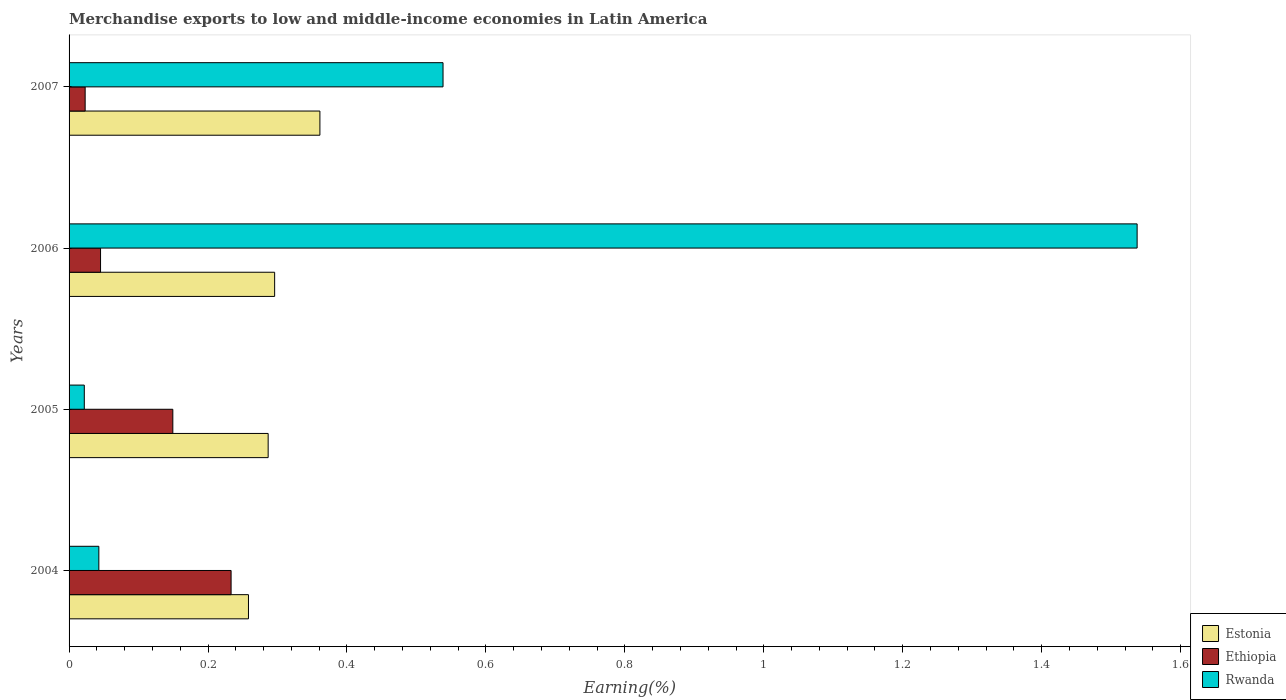How many different coloured bars are there?
Offer a very short reply. 3. How many groups of bars are there?
Offer a terse response. 4. How many bars are there on the 3rd tick from the bottom?
Provide a short and direct response. 3. What is the label of the 1st group of bars from the top?
Your response must be concise. 2007. In how many cases, is the number of bars for a given year not equal to the number of legend labels?
Give a very brief answer. 0. What is the percentage of amount earned from merchandise exports in Ethiopia in 2006?
Offer a very short reply. 0.05. Across all years, what is the maximum percentage of amount earned from merchandise exports in Estonia?
Keep it short and to the point. 0.36. Across all years, what is the minimum percentage of amount earned from merchandise exports in Rwanda?
Your response must be concise. 0.02. In which year was the percentage of amount earned from merchandise exports in Rwanda maximum?
Your answer should be compact. 2006. What is the total percentage of amount earned from merchandise exports in Ethiopia in the graph?
Provide a succinct answer. 0.45. What is the difference between the percentage of amount earned from merchandise exports in Ethiopia in 2004 and that in 2007?
Keep it short and to the point. 0.21. What is the difference between the percentage of amount earned from merchandise exports in Estonia in 2004 and the percentage of amount earned from merchandise exports in Ethiopia in 2007?
Offer a terse response. 0.24. What is the average percentage of amount earned from merchandise exports in Ethiopia per year?
Your response must be concise. 0.11. In the year 2007, what is the difference between the percentage of amount earned from merchandise exports in Rwanda and percentage of amount earned from merchandise exports in Estonia?
Provide a succinct answer. 0.18. In how many years, is the percentage of amount earned from merchandise exports in Rwanda greater than 1 %?
Keep it short and to the point. 1. What is the ratio of the percentage of amount earned from merchandise exports in Estonia in 2005 to that in 2007?
Offer a terse response. 0.79. Is the percentage of amount earned from merchandise exports in Ethiopia in 2004 less than that in 2005?
Provide a succinct answer. No. Is the difference between the percentage of amount earned from merchandise exports in Rwanda in 2004 and 2006 greater than the difference between the percentage of amount earned from merchandise exports in Estonia in 2004 and 2006?
Provide a short and direct response. No. What is the difference between the highest and the second highest percentage of amount earned from merchandise exports in Ethiopia?
Offer a terse response. 0.08. What is the difference between the highest and the lowest percentage of amount earned from merchandise exports in Estonia?
Your response must be concise. 0.1. What does the 3rd bar from the top in 2006 represents?
Offer a very short reply. Estonia. What does the 3rd bar from the bottom in 2005 represents?
Offer a very short reply. Rwanda. How many bars are there?
Give a very brief answer. 12. Are all the bars in the graph horizontal?
Your answer should be very brief. Yes. How many years are there in the graph?
Give a very brief answer. 4. Are the values on the major ticks of X-axis written in scientific E-notation?
Your answer should be compact. No. Does the graph contain grids?
Offer a very short reply. No. Where does the legend appear in the graph?
Ensure brevity in your answer.  Bottom right. How are the legend labels stacked?
Make the answer very short. Vertical. What is the title of the graph?
Offer a very short reply. Merchandise exports to low and middle-income economies in Latin America. Does "Peru" appear as one of the legend labels in the graph?
Your answer should be compact. No. What is the label or title of the X-axis?
Give a very brief answer. Earning(%). What is the label or title of the Y-axis?
Keep it short and to the point. Years. What is the Earning(%) in Estonia in 2004?
Offer a terse response. 0.26. What is the Earning(%) in Ethiopia in 2004?
Offer a very short reply. 0.23. What is the Earning(%) in Rwanda in 2004?
Provide a short and direct response. 0.04. What is the Earning(%) in Estonia in 2005?
Give a very brief answer. 0.29. What is the Earning(%) in Ethiopia in 2005?
Make the answer very short. 0.15. What is the Earning(%) of Rwanda in 2005?
Your answer should be compact. 0.02. What is the Earning(%) of Estonia in 2006?
Ensure brevity in your answer.  0.3. What is the Earning(%) in Ethiopia in 2006?
Keep it short and to the point. 0.05. What is the Earning(%) in Rwanda in 2006?
Make the answer very short. 1.54. What is the Earning(%) in Estonia in 2007?
Your answer should be very brief. 0.36. What is the Earning(%) in Ethiopia in 2007?
Keep it short and to the point. 0.02. What is the Earning(%) in Rwanda in 2007?
Your answer should be very brief. 0.54. Across all years, what is the maximum Earning(%) of Estonia?
Give a very brief answer. 0.36. Across all years, what is the maximum Earning(%) in Ethiopia?
Your answer should be compact. 0.23. Across all years, what is the maximum Earning(%) in Rwanda?
Ensure brevity in your answer.  1.54. Across all years, what is the minimum Earning(%) of Estonia?
Offer a terse response. 0.26. Across all years, what is the minimum Earning(%) of Ethiopia?
Give a very brief answer. 0.02. Across all years, what is the minimum Earning(%) of Rwanda?
Provide a succinct answer. 0.02. What is the total Earning(%) of Estonia in the graph?
Your answer should be very brief. 1.2. What is the total Earning(%) in Ethiopia in the graph?
Ensure brevity in your answer.  0.45. What is the total Earning(%) in Rwanda in the graph?
Provide a short and direct response. 2.14. What is the difference between the Earning(%) of Estonia in 2004 and that in 2005?
Your answer should be very brief. -0.03. What is the difference between the Earning(%) in Ethiopia in 2004 and that in 2005?
Provide a short and direct response. 0.08. What is the difference between the Earning(%) in Rwanda in 2004 and that in 2005?
Offer a terse response. 0.02. What is the difference between the Earning(%) in Estonia in 2004 and that in 2006?
Provide a short and direct response. -0.04. What is the difference between the Earning(%) of Ethiopia in 2004 and that in 2006?
Make the answer very short. 0.19. What is the difference between the Earning(%) of Rwanda in 2004 and that in 2006?
Your answer should be compact. -1.49. What is the difference between the Earning(%) in Estonia in 2004 and that in 2007?
Give a very brief answer. -0.1. What is the difference between the Earning(%) in Ethiopia in 2004 and that in 2007?
Keep it short and to the point. 0.21. What is the difference between the Earning(%) of Rwanda in 2004 and that in 2007?
Your answer should be compact. -0.5. What is the difference between the Earning(%) in Estonia in 2005 and that in 2006?
Give a very brief answer. -0.01. What is the difference between the Earning(%) in Ethiopia in 2005 and that in 2006?
Offer a very short reply. 0.1. What is the difference between the Earning(%) in Rwanda in 2005 and that in 2006?
Provide a short and direct response. -1.52. What is the difference between the Earning(%) in Estonia in 2005 and that in 2007?
Give a very brief answer. -0.07. What is the difference between the Earning(%) of Ethiopia in 2005 and that in 2007?
Ensure brevity in your answer.  0.13. What is the difference between the Earning(%) in Rwanda in 2005 and that in 2007?
Ensure brevity in your answer.  -0.52. What is the difference between the Earning(%) of Estonia in 2006 and that in 2007?
Make the answer very short. -0.07. What is the difference between the Earning(%) of Ethiopia in 2006 and that in 2007?
Your answer should be very brief. 0.02. What is the difference between the Earning(%) of Rwanda in 2006 and that in 2007?
Offer a terse response. 1. What is the difference between the Earning(%) of Estonia in 2004 and the Earning(%) of Ethiopia in 2005?
Give a very brief answer. 0.11. What is the difference between the Earning(%) of Estonia in 2004 and the Earning(%) of Rwanda in 2005?
Your answer should be very brief. 0.24. What is the difference between the Earning(%) in Ethiopia in 2004 and the Earning(%) in Rwanda in 2005?
Your response must be concise. 0.21. What is the difference between the Earning(%) in Estonia in 2004 and the Earning(%) in Ethiopia in 2006?
Keep it short and to the point. 0.21. What is the difference between the Earning(%) of Estonia in 2004 and the Earning(%) of Rwanda in 2006?
Keep it short and to the point. -1.28. What is the difference between the Earning(%) in Ethiopia in 2004 and the Earning(%) in Rwanda in 2006?
Provide a short and direct response. -1.3. What is the difference between the Earning(%) in Estonia in 2004 and the Earning(%) in Ethiopia in 2007?
Make the answer very short. 0.24. What is the difference between the Earning(%) in Estonia in 2004 and the Earning(%) in Rwanda in 2007?
Provide a short and direct response. -0.28. What is the difference between the Earning(%) of Ethiopia in 2004 and the Earning(%) of Rwanda in 2007?
Keep it short and to the point. -0.31. What is the difference between the Earning(%) in Estonia in 2005 and the Earning(%) in Ethiopia in 2006?
Provide a succinct answer. 0.24. What is the difference between the Earning(%) in Estonia in 2005 and the Earning(%) in Rwanda in 2006?
Ensure brevity in your answer.  -1.25. What is the difference between the Earning(%) of Ethiopia in 2005 and the Earning(%) of Rwanda in 2006?
Your answer should be very brief. -1.39. What is the difference between the Earning(%) of Estonia in 2005 and the Earning(%) of Ethiopia in 2007?
Keep it short and to the point. 0.26. What is the difference between the Earning(%) in Estonia in 2005 and the Earning(%) in Rwanda in 2007?
Make the answer very short. -0.25. What is the difference between the Earning(%) of Ethiopia in 2005 and the Earning(%) of Rwanda in 2007?
Ensure brevity in your answer.  -0.39. What is the difference between the Earning(%) of Estonia in 2006 and the Earning(%) of Ethiopia in 2007?
Give a very brief answer. 0.27. What is the difference between the Earning(%) in Estonia in 2006 and the Earning(%) in Rwanda in 2007?
Provide a short and direct response. -0.24. What is the difference between the Earning(%) in Ethiopia in 2006 and the Earning(%) in Rwanda in 2007?
Provide a short and direct response. -0.49. What is the average Earning(%) of Estonia per year?
Your response must be concise. 0.3. What is the average Earning(%) in Ethiopia per year?
Your answer should be compact. 0.11. What is the average Earning(%) of Rwanda per year?
Provide a short and direct response. 0.54. In the year 2004, what is the difference between the Earning(%) of Estonia and Earning(%) of Ethiopia?
Offer a terse response. 0.03. In the year 2004, what is the difference between the Earning(%) in Estonia and Earning(%) in Rwanda?
Offer a terse response. 0.22. In the year 2004, what is the difference between the Earning(%) of Ethiopia and Earning(%) of Rwanda?
Offer a terse response. 0.19. In the year 2005, what is the difference between the Earning(%) of Estonia and Earning(%) of Ethiopia?
Ensure brevity in your answer.  0.14. In the year 2005, what is the difference between the Earning(%) of Estonia and Earning(%) of Rwanda?
Provide a short and direct response. 0.26. In the year 2005, what is the difference between the Earning(%) in Ethiopia and Earning(%) in Rwanda?
Your answer should be compact. 0.13. In the year 2006, what is the difference between the Earning(%) in Estonia and Earning(%) in Ethiopia?
Offer a terse response. 0.25. In the year 2006, what is the difference between the Earning(%) in Estonia and Earning(%) in Rwanda?
Provide a succinct answer. -1.24. In the year 2006, what is the difference between the Earning(%) of Ethiopia and Earning(%) of Rwanda?
Provide a short and direct response. -1.49. In the year 2007, what is the difference between the Earning(%) of Estonia and Earning(%) of Ethiopia?
Offer a very short reply. 0.34. In the year 2007, what is the difference between the Earning(%) in Estonia and Earning(%) in Rwanda?
Your answer should be compact. -0.18. In the year 2007, what is the difference between the Earning(%) of Ethiopia and Earning(%) of Rwanda?
Make the answer very short. -0.52. What is the ratio of the Earning(%) in Estonia in 2004 to that in 2005?
Your answer should be very brief. 0.9. What is the ratio of the Earning(%) of Ethiopia in 2004 to that in 2005?
Your answer should be very brief. 1.56. What is the ratio of the Earning(%) in Rwanda in 2004 to that in 2005?
Offer a very short reply. 1.96. What is the ratio of the Earning(%) in Estonia in 2004 to that in 2006?
Give a very brief answer. 0.87. What is the ratio of the Earning(%) in Ethiopia in 2004 to that in 2006?
Make the answer very short. 5.15. What is the ratio of the Earning(%) in Rwanda in 2004 to that in 2006?
Your response must be concise. 0.03. What is the ratio of the Earning(%) in Estonia in 2004 to that in 2007?
Offer a very short reply. 0.72. What is the ratio of the Earning(%) of Ethiopia in 2004 to that in 2007?
Give a very brief answer. 10.08. What is the ratio of the Earning(%) of Rwanda in 2004 to that in 2007?
Make the answer very short. 0.08. What is the ratio of the Earning(%) in Estonia in 2005 to that in 2006?
Your response must be concise. 0.97. What is the ratio of the Earning(%) in Ethiopia in 2005 to that in 2006?
Make the answer very short. 3.3. What is the ratio of the Earning(%) of Rwanda in 2005 to that in 2006?
Your response must be concise. 0.01. What is the ratio of the Earning(%) of Estonia in 2005 to that in 2007?
Provide a short and direct response. 0.79. What is the ratio of the Earning(%) in Ethiopia in 2005 to that in 2007?
Offer a terse response. 6.45. What is the ratio of the Earning(%) of Rwanda in 2005 to that in 2007?
Your answer should be compact. 0.04. What is the ratio of the Earning(%) in Estonia in 2006 to that in 2007?
Offer a very short reply. 0.82. What is the ratio of the Earning(%) of Ethiopia in 2006 to that in 2007?
Provide a succinct answer. 1.96. What is the ratio of the Earning(%) in Rwanda in 2006 to that in 2007?
Your response must be concise. 2.86. What is the difference between the highest and the second highest Earning(%) of Estonia?
Offer a terse response. 0.07. What is the difference between the highest and the second highest Earning(%) of Ethiopia?
Provide a succinct answer. 0.08. What is the difference between the highest and the second highest Earning(%) of Rwanda?
Offer a very short reply. 1. What is the difference between the highest and the lowest Earning(%) of Estonia?
Offer a terse response. 0.1. What is the difference between the highest and the lowest Earning(%) in Ethiopia?
Your answer should be very brief. 0.21. What is the difference between the highest and the lowest Earning(%) in Rwanda?
Provide a short and direct response. 1.52. 